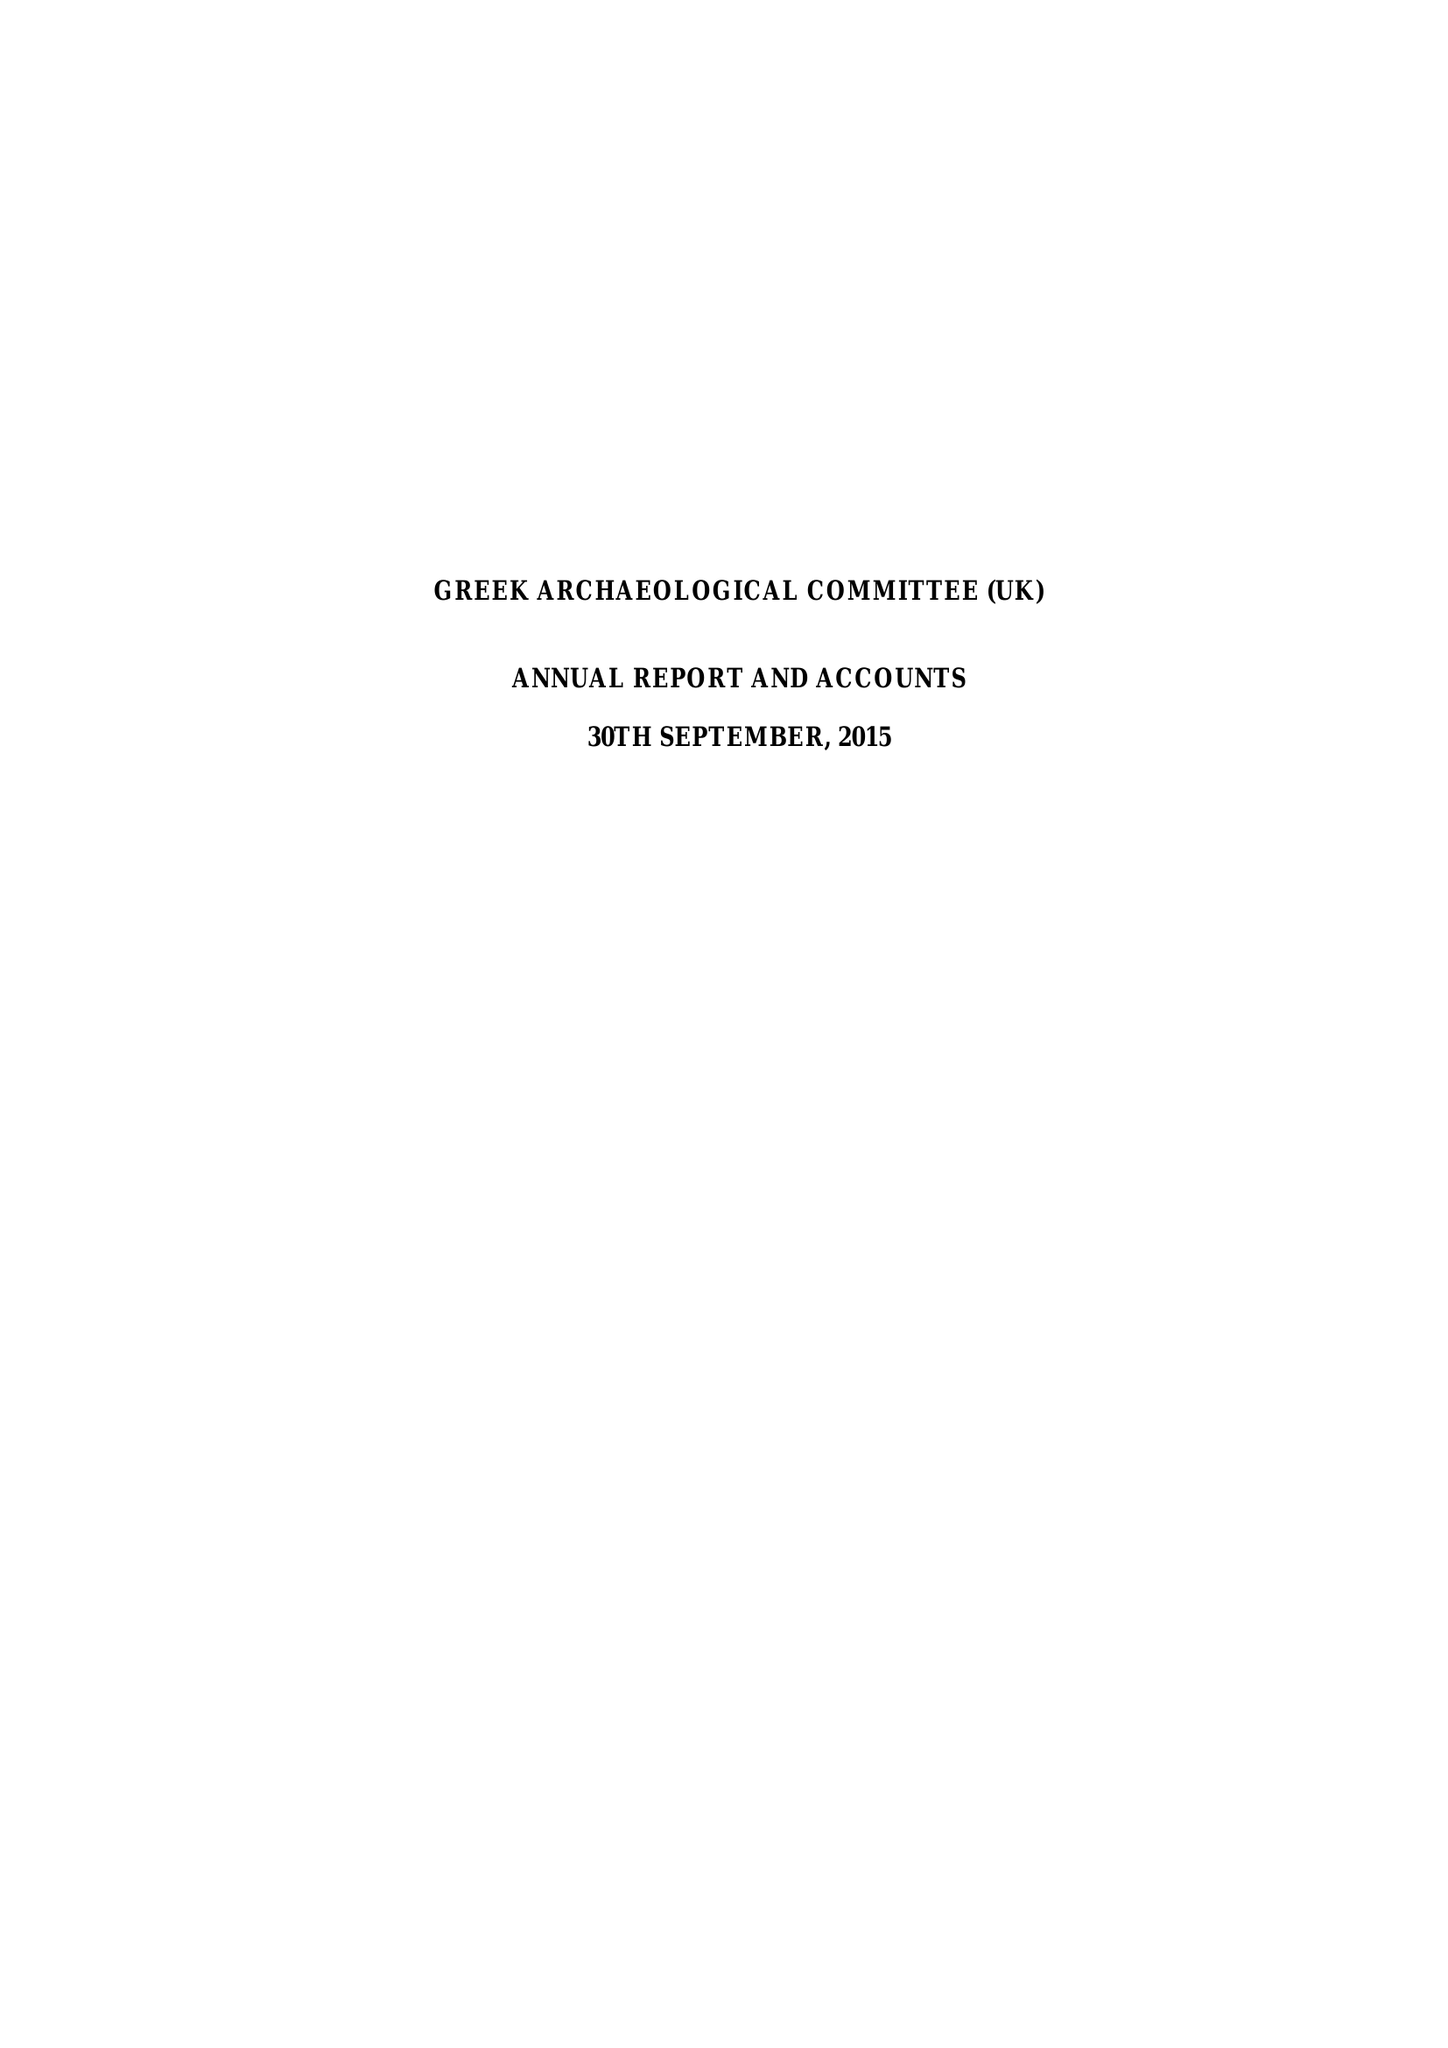What is the value for the spending_annually_in_british_pounds?
Answer the question using a single word or phrase. 43082.00 